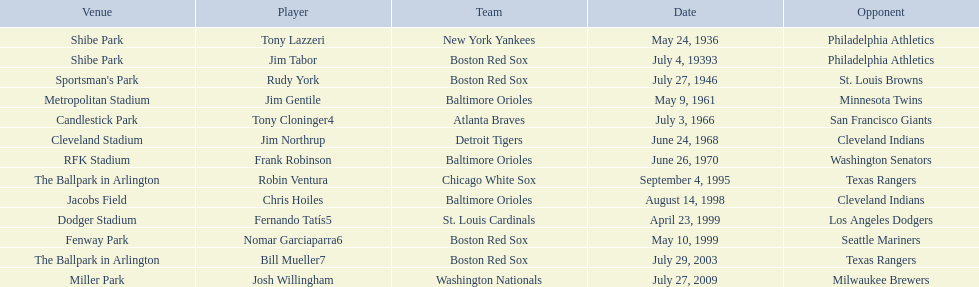Who was the opponent for the boston red sox on july 27, 1946? St. Louis Browns. 